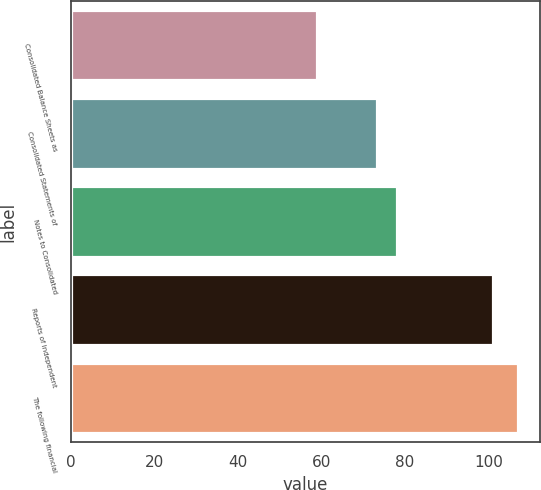Convert chart. <chart><loc_0><loc_0><loc_500><loc_500><bar_chart><fcel>Consolidated Balance Sheets as<fcel>Consolidated Statements of<fcel>Notes to Consolidated<fcel>Reports of Independent<fcel>The following financial<nl><fcel>59<fcel>73.4<fcel>78.2<fcel>101<fcel>107<nl></chart> 